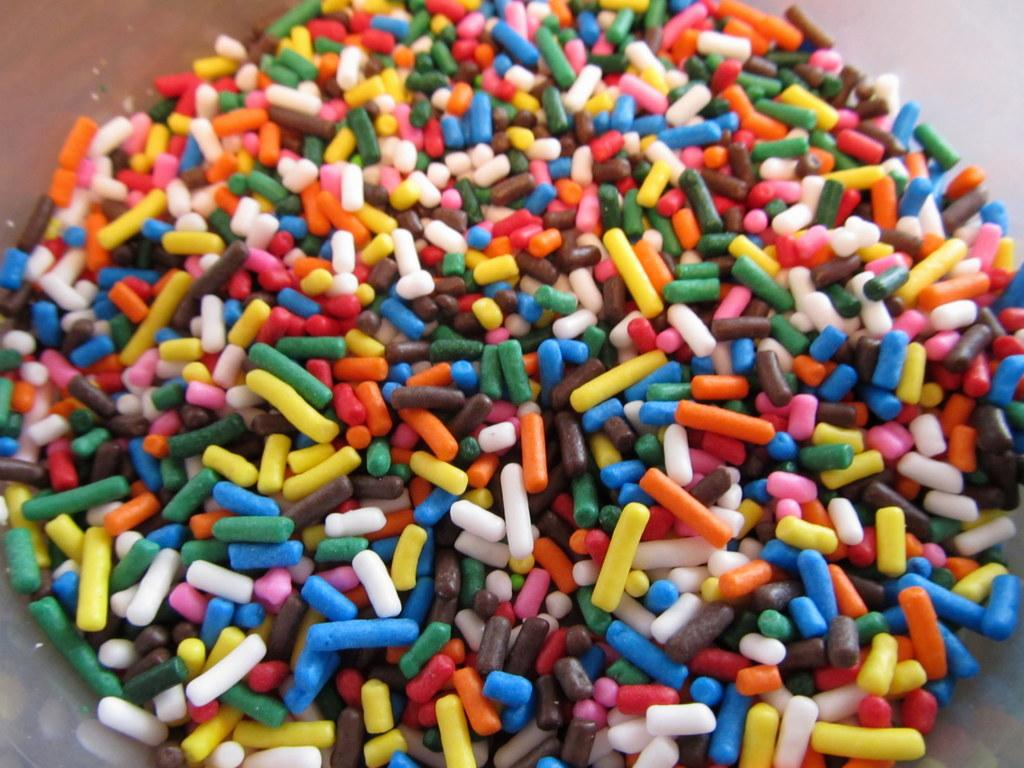What type of objects are in the image? There are comfits in the image. Can you describe the appearance of the comfits? The comfits are in different colors. On what surface are the comfits placed? The comfits are placed on a brown table. What type of dinosaurs can be seen in the image? There are no dinosaurs present in the image; it features comfits on a brown table. What type of lumber is used to make the table in the image? The image does not provide information about the type of lumber used to make the table. 